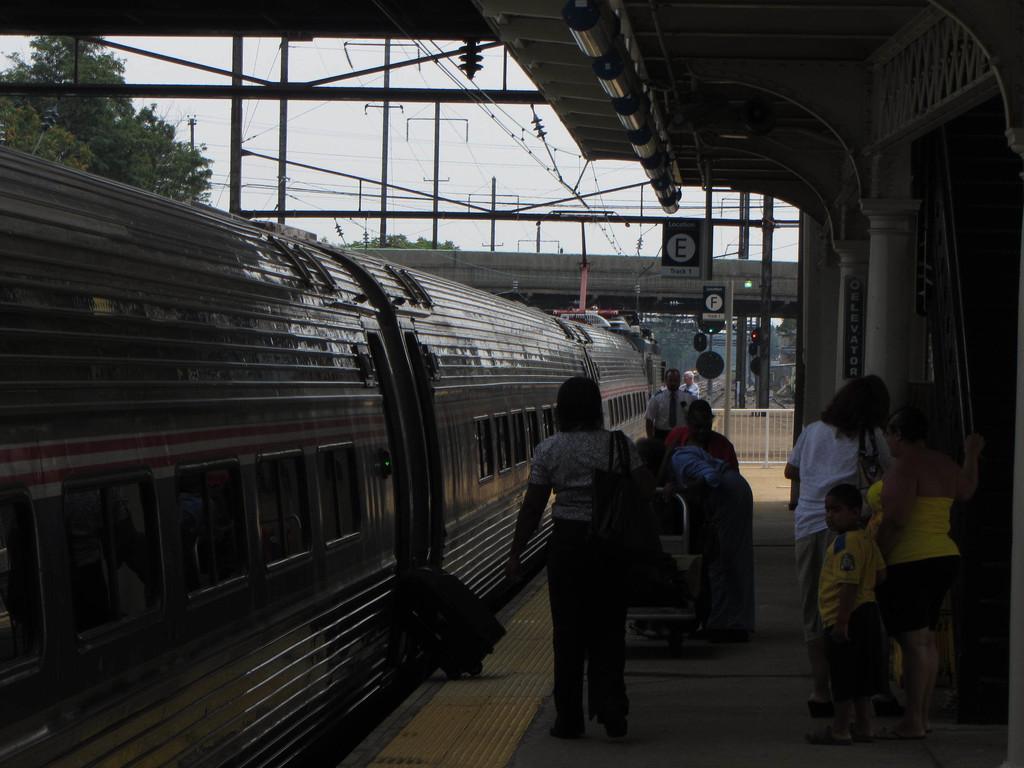Describe this image in one or two sentences. This image is taken at the railway station. There is a train in the image. There are people standing at the station. There are electric poles. There is a tree in the image. 